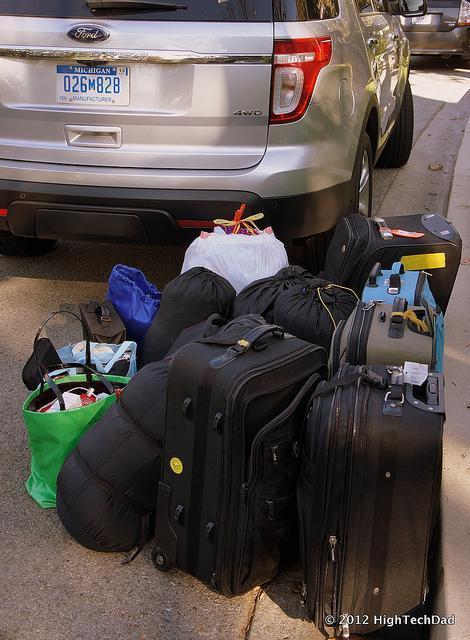How many suitcases are visible?
Give a very brief answer. 5. How many cars can you see?
Give a very brief answer. 2. How many handbags are there?
Give a very brief answer. 3. How many kites are in the sky?
Give a very brief answer. 0. 